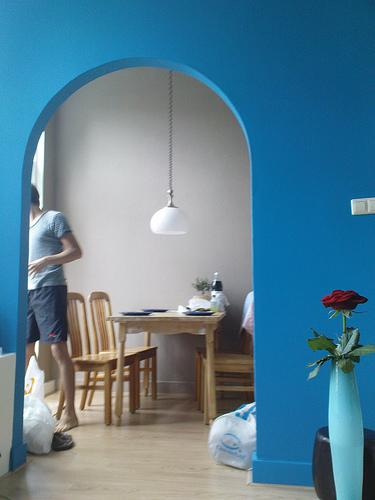Describe the scene using elaborate and sophisticated language. In the elegantly adorned dining area, with a blue wall providing a serene backdrop, a contemplative gentleman, sans footwear, pauses to peer through the window, whilst abandoning a pallid plastic receptacle near the exquisitely arranged wooden table. Describe the room's interior and the man's action in a concise manner. Man in dining room, with table and chairs, peers out window and leaves white bag on wooden floor. Provide a brief summary of the scene depicted in the image. A barefoot man stands in his dining room, preparing to take out garbage, and peers outside while leaving a white plastic bag on the floor. Write about the key aspects of the image in an informal tone. So, there's this barefoot guy looking out the window in his dining room with a blue wall, wooden table, and a bunch of stuff hanging around, like a light and a pretty vase with a red rose. Mention the man's action and the notable objects in the room in a casual and friendly tone. Hey, there's a guy standing by the window without shoes, just taking a look outside while in his cozy dining room, with a nice table, chairs, and a cute vase with a red rose in it. State what is happening in the image using simple words and short sentences. Man looking out window. Dining room with table, chairs, and blue wall. White bag on the floor. Mention the man's activity and the surrounding elements in a passive voice. The window is being peered out by a barefoot man, while a white plastic bag is being left on the floor of the dining room. Describe the dining room and its contents in a factual manner. The dining room features a blue wall, wooden floor, table with dishes, chairs, a hanging lamp, and a red rose in a blue vase. Describe the visual elements of the picture using an artistic perspective. A harmonious composition portraying a pensive, barefoot man standing amid the gentle allure of a dining room adorned with a blue wall, a wooden table, chairs, and subtle accents like a hanging lamp and vibrant red rose. Write a creative description of the main scenario in the image. Lost in thought, a barefoot man momentarily gazes out the window, as he pauses from his task of taking the garbage out from his dining room. 